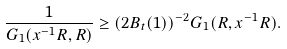<formula> <loc_0><loc_0><loc_500><loc_500>\frac { 1 } { G _ { 1 } ( x ^ { - 1 } R , R ) } \geq ( 2 B _ { t } ( 1 ) ) ^ { - 2 } G _ { 1 } ( R , x ^ { - 1 } R ) .</formula> 